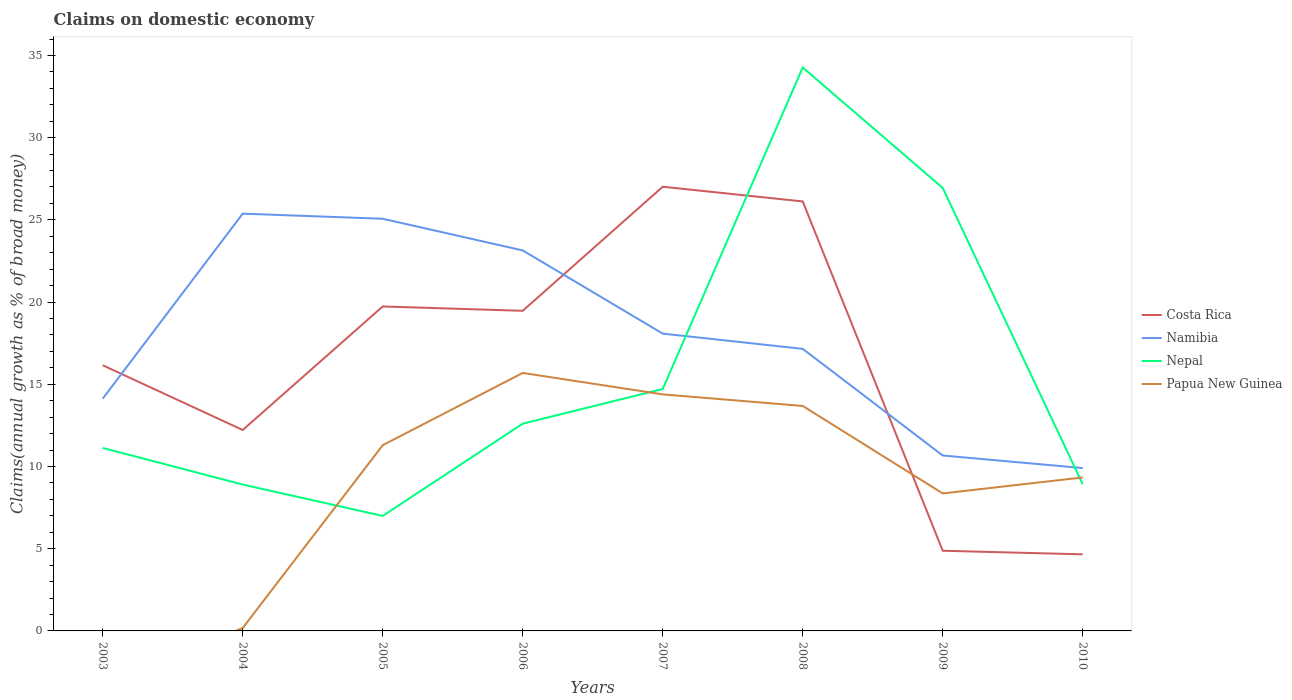How many different coloured lines are there?
Make the answer very short. 4. Does the line corresponding to Nepal intersect with the line corresponding to Papua New Guinea?
Make the answer very short. Yes. Is the number of lines equal to the number of legend labels?
Offer a terse response. No. Across all years, what is the maximum percentage of broad money claimed on domestic economy in Costa Rica?
Give a very brief answer. 4.66. What is the total percentage of broad money claimed on domestic economy in Namibia in the graph?
Your response must be concise. 8.22. What is the difference between the highest and the second highest percentage of broad money claimed on domestic economy in Papua New Guinea?
Your response must be concise. 15.69. What is the difference between the highest and the lowest percentage of broad money claimed on domestic economy in Nepal?
Offer a terse response. 2. Does the graph contain grids?
Provide a short and direct response. No. How are the legend labels stacked?
Provide a succinct answer. Vertical. What is the title of the graph?
Your answer should be very brief. Claims on domestic economy. Does "Czech Republic" appear as one of the legend labels in the graph?
Your answer should be very brief. No. What is the label or title of the X-axis?
Provide a short and direct response. Years. What is the label or title of the Y-axis?
Your answer should be very brief. Claims(annual growth as % of broad money). What is the Claims(annual growth as % of broad money) in Costa Rica in 2003?
Provide a succinct answer. 16.16. What is the Claims(annual growth as % of broad money) in Namibia in 2003?
Keep it short and to the point. 14.13. What is the Claims(annual growth as % of broad money) of Nepal in 2003?
Give a very brief answer. 11.13. What is the Claims(annual growth as % of broad money) of Papua New Guinea in 2003?
Offer a terse response. 0. What is the Claims(annual growth as % of broad money) in Costa Rica in 2004?
Keep it short and to the point. 12.22. What is the Claims(annual growth as % of broad money) in Namibia in 2004?
Provide a short and direct response. 25.38. What is the Claims(annual growth as % of broad money) of Nepal in 2004?
Keep it short and to the point. 8.9. What is the Claims(annual growth as % of broad money) in Papua New Guinea in 2004?
Offer a terse response. 0.18. What is the Claims(annual growth as % of broad money) of Costa Rica in 2005?
Provide a succinct answer. 19.73. What is the Claims(annual growth as % of broad money) of Namibia in 2005?
Keep it short and to the point. 25.07. What is the Claims(annual growth as % of broad money) of Nepal in 2005?
Your answer should be very brief. 6.99. What is the Claims(annual growth as % of broad money) of Papua New Guinea in 2005?
Your answer should be compact. 11.3. What is the Claims(annual growth as % of broad money) in Costa Rica in 2006?
Your answer should be compact. 19.47. What is the Claims(annual growth as % of broad money) of Namibia in 2006?
Offer a terse response. 23.14. What is the Claims(annual growth as % of broad money) of Nepal in 2006?
Give a very brief answer. 12.61. What is the Claims(annual growth as % of broad money) in Papua New Guinea in 2006?
Your answer should be compact. 15.69. What is the Claims(annual growth as % of broad money) of Costa Rica in 2007?
Make the answer very short. 27.02. What is the Claims(annual growth as % of broad money) in Namibia in 2007?
Offer a terse response. 18.08. What is the Claims(annual growth as % of broad money) of Nepal in 2007?
Provide a short and direct response. 14.71. What is the Claims(annual growth as % of broad money) of Papua New Guinea in 2007?
Your answer should be very brief. 14.39. What is the Claims(annual growth as % of broad money) of Costa Rica in 2008?
Your answer should be very brief. 26.12. What is the Claims(annual growth as % of broad money) of Namibia in 2008?
Give a very brief answer. 17.15. What is the Claims(annual growth as % of broad money) of Nepal in 2008?
Your answer should be compact. 34.27. What is the Claims(annual growth as % of broad money) in Papua New Guinea in 2008?
Ensure brevity in your answer.  13.68. What is the Claims(annual growth as % of broad money) in Costa Rica in 2009?
Give a very brief answer. 4.88. What is the Claims(annual growth as % of broad money) in Namibia in 2009?
Make the answer very short. 10.67. What is the Claims(annual growth as % of broad money) of Nepal in 2009?
Ensure brevity in your answer.  26.94. What is the Claims(annual growth as % of broad money) of Papua New Guinea in 2009?
Your response must be concise. 8.36. What is the Claims(annual growth as % of broad money) in Costa Rica in 2010?
Make the answer very short. 4.66. What is the Claims(annual growth as % of broad money) in Namibia in 2010?
Your answer should be compact. 9.9. What is the Claims(annual growth as % of broad money) of Nepal in 2010?
Your response must be concise. 8.92. What is the Claims(annual growth as % of broad money) in Papua New Guinea in 2010?
Give a very brief answer. 9.33. Across all years, what is the maximum Claims(annual growth as % of broad money) of Costa Rica?
Your answer should be very brief. 27.02. Across all years, what is the maximum Claims(annual growth as % of broad money) in Namibia?
Your answer should be compact. 25.38. Across all years, what is the maximum Claims(annual growth as % of broad money) in Nepal?
Give a very brief answer. 34.27. Across all years, what is the maximum Claims(annual growth as % of broad money) in Papua New Guinea?
Provide a succinct answer. 15.69. Across all years, what is the minimum Claims(annual growth as % of broad money) of Costa Rica?
Your response must be concise. 4.66. Across all years, what is the minimum Claims(annual growth as % of broad money) in Namibia?
Your response must be concise. 9.9. Across all years, what is the minimum Claims(annual growth as % of broad money) in Nepal?
Offer a very short reply. 6.99. What is the total Claims(annual growth as % of broad money) in Costa Rica in the graph?
Provide a short and direct response. 130.25. What is the total Claims(annual growth as % of broad money) of Namibia in the graph?
Provide a short and direct response. 143.52. What is the total Claims(annual growth as % of broad money) in Nepal in the graph?
Keep it short and to the point. 124.47. What is the total Claims(annual growth as % of broad money) in Papua New Guinea in the graph?
Provide a short and direct response. 72.93. What is the difference between the Claims(annual growth as % of broad money) in Costa Rica in 2003 and that in 2004?
Offer a very short reply. 3.94. What is the difference between the Claims(annual growth as % of broad money) of Namibia in 2003 and that in 2004?
Give a very brief answer. -11.25. What is the difference between the Claims(annual growth as % of broad money) of Nepal in 2003 and that in 2004?
Offer a very short reply. 2.23. What is the difference between the Claims(annual growth as % of broad money) of Costa Rica in 2003 and that in 2005?
Keep it short and to the point. -3.58. What is the difference between the Claims(annual growth as % of broad money) in Namibia in 2003 and that in 2005?
Ensure brevity in your answer.  -10.94. What is the difference between the Claims(annual growth as % of broad money) of Nepal in 2003 and that in 2005?
Provide a short and direct response. 4.14. What is the difference between the Claims(annual growth as % of broad money) of Costa Rica in 2003 and that in 2006?
Provide a succinct answer. -3.31. What is the difference between the Claims(annual growth as % of broad money) in Namibia in 2003 and that in 2006?
Provide a succinct answer. -9.02. What is the difference between the Claims(annual growth as % of broad money) in Nepal in 2003 and that in 2006?
Make the answer very short. -1.48. What is the difference between the Claims(annual growth as % of broad money) in Costa Rica in 2003 and that in 2007?
Offer a terse response. -10.86. What is the difference between the Claims(annual growth as % of broad money) in Namibia in 2003 and that in 2007?
Ensure brevity in your answer.  -3.96. What is the difference between the Claims(annual growth as % of broad money) in Nepal in 2003 and that in 2007?
Offer a very short reply. -3.58. What is the difference between the Claims(annual growth as % of broad money) of Costa Rica in 2003 and that in 2008?
Offer a terse response. -9.96. What is the difference between the Claims(annual growth as % of broad money) in Namibia in 2003 and that in 2008?
Keep it short and to the point. -3.03. What is the difference between the Claims(annual growth as % of broad money) in Nepal in 2003 and that in 2008?
Your response must be concise. -23.14. What is the difference between the Claims(annual growth as % of broad money) of Costa Rica in 2003 and that in 2009?
Your answer should be compact. 11.28. What is the difference between the Claims(annual growth as % of broad money) of Namibia in 2003 and that in 2009?
Give a very brief answer. 3.46. What is the difference between the Claims(annual growth as % of broad money) in Nepal in 2003 and that in 2009?
Your answer should be compact. -15.81. What is the difference between the Claims(annual growth as % of broad money) of Costa Rica in 2003 and that in 2010?
Your answer should be compact. 11.5. What is the difference between the Claims(annual growth as % of broad money) in Namibia in 2003 and that in 2010?
Your response must be concise. 4.22. What is the difference between the Claims(annual growth as % of broad money) in Nepal in 2003 and that in 2010?
Give a very brief answer. 2.21. What is the difference between the Claims(annual growth as % of broad money) of Costa Rica in 2004 and that in 2005?
Your response must be concise. -7.51. What is the difference between the Claims(annual growth as % of broad money) in Namibia in 2004 and that in 2005?
Keep it short and to the point. 0.31. What is the difference between the Claims(annual growth as % of broad money) of Nepal in 2004 and that in 2005?
Offer a terse response. 1.91. What is the difference between the Claims(annual growth as % of broad money) of Papua New Guinea in 2004 and that in 2005?
Make the answer very short. -11.12. What is the difference between the Claims(annual growth as % of broad money) of Costa Rica in 2004 and that in 2006?
Your answer should be very brief. -7.25. What is the difference between the Claims(annual growth as % of broad money) in Namibia in 2004 and that in 2006?
Your answer should be very brief. 2.24. What is the difference between the Claims(annual growth as % of broad money) in Nepal in 2004 and that in 2006?
Offer a very short reply. -3.7. What is the difference between the Claims(annual growth as % of broad money) in Papua New Guinea in 2004 and that in 2006?
Ensure brevity in your answer.  -15.51. What is the difference between the Claims(annual growth as % of broad money) in Costa Rica in 2004 and that in 2007?
Offer a very short reply. -14.8. What is the difference between the Claims(annual growth as % of broad money) of Namibia in 2004 and that in 2007?
Your answer should be very brief. 7.3. What is the difference between the Claims(annual growth as % of broad money) of Nepal in 2004 and that in 2007?
Offer a very short reply. -5.81. What is the difference between the Claims(annual growth as % of broad money) in Papua New Guinea in 2004 and that in 2007?
Keep it short and to the point. -14.21. What is the difference between the Claims(annual growth as % of broad money) of Costa Rica in 2004 and that in 2008?
Provide a short and direct response. -13.9. What is the difference between the Claims(annual growth as % of broad money) in Namibia in 2004 and that in 2008?
Your answer should be very brief. 8.22. What is the difference between the Claims(annual growth as % of broad money) of Nepal in 2004 and that in 2008?
Ensure brevity in your answer.  -25.37. What is the difference between the Claims(annual growth as % of broad money) of Papua New Guinea in 2004 and that in 2008?
Give a very brief answer. -13.5. What is the difference between the Claims(annual growth as % of broad money) in Costa Rica in 2004 and that in 2009?
Your answer should be very brief. 7.34. What is the difference between the Claims(annual growth as % of broad money) of Namibia in 2004 and that in 2009?
Keep it short and to the point. 14.71. What is the difference between the Claims(annual growth as % of broad money) in Nepal in 2004 and that in 2009?
Provide a short and direct response. -18.04. What is the difference between the Claims(annual growth as % of broad money) of Papua New Guinea in 2004 and that in 2009?
Provide a short and direct response. -8.18. What is the difference between the Claims(annual growth as % of broad money) in Costa Rica in 2004 and that in 2010?
Keep it short and to the point. 7.56. What is the difference between the Claims(annual growth as % of broad money) in Namibia in 2004 and that in 2010?
Your answer should be compact. 15.48. What is the difference between the Claims(annual growth as % of broad money) of Nepal in 2004 and that in 2010?
Provide a succinct answer. -0.02. What is the difference between the Claims(annual growth as % of broad money) of Papua New Guinea in 2004 and that in 2010?
Your answer should be compact. -9.15. What is the difference between the Claims(annual growth as % of broad money) in Costa Rica in 2005 and that in 2006?
Offer a terse response. 0.26. What is the difference between the Claims(annual growth as % of broad money) of Namibia in 2005 and that in 2006?
Your answer should be very brief. 1.93. What is the difference between the Claims(annual growth as % of broad money) of Nepal in 2005 and that in 2006?
Your answer should be very brief. -5.61. What is the difference between the Claims(annual growth as % of broad money) of Papua New Guinea in 2005 and that in 2006?
Your response must be concise. -4.4. What is the difference between the Claims(annual growth as % of broad money) of Costa Rica in 2005 and that in 2007?
Provide a short and direct response. -7.28. What is the difference between the Claims(annual growth as % of broad money) of Namibia in 2005 and that in 2007?
Ensure brevity in your answer.  6.99. What is the difference between the Claims(annual growth as % of broad money) in Nepal in 2005 and that in 2007?
Offer a terse response. -7.72. What is the difference between the Claims(annual growth as % of broad money) in Papua New Guinea in 2005 and that in 2007?
Offer a terse response. -3.09. What is the difference between the Claims(annual growth as % of broad money) in Costa Rica in 2005 and that in 2008?
Make the answer very short. -6.39. What is the difference between the Claims(annual growth as % of broad money) of Namibia in 2005 and that in 2008?
Keep it short and to the point. 7.91. What is the difference between the Claims(annual growth as % of broad money) of Nepal in 2005 and that in 2008?
Keep it short and to the point. -27.27. What is the difference between the Claims(annual growth as % of broad money) in Papua New Guinea in 2005 and that in 2008?
Provide a succinct answer. -2.39. What is the difference between the Claims(annual growth as % of broad money) in Costa Rica in 2005 and that in 2009?
Make the answer very short. 14.86. What is the difference between the Claims(annual growth as % of broad money) in Namibia in 2005 and that in 2009?
Your answer should be compact. 14.4. What is the difference between the Claims(annual growth as % of broad money) in Nepal in 2005 and that in 2009?
Keep it short and to the point. -19.95. What is the difference between the Claims(annual growth as % of broad money) of Papua New Guinea in 2005 and that in 2009?
Offer a very short reply. 2.93. What is the difference between the Claims(annual growth as % of broad money) in Costa Rica in 2005 and that in 2010?
Give a very brief answer. 15.08. What is the difference between the Claims(annual growth as % of broad money) of Namibia in 2005 and that in 2010?
Make the answer very short. 15.16. What is the difference between the Claims(annual growth as % of broad money) of Nepal in 2005 and that in 2010?
Your answer should be very brief. -1.93. What is the difference between the Claims(annual growth as % of broad money) of Papua New Guinea in 2005 and that in 2010?
Offer a terse response. 1.96. What is the difference between the Claims(annual growth as % of broad money) in Costa Rica in 2006 and that in 2007?
Ensure brevity in your answer.  -7.55. What is the difference between the Claims(annual growth as % of broad money) in Namibia in 2006 and that in 2007?
Offer a terse response. 5.06. What is the difference between the Claims(annual growth as % of broad money) in Nepal in 2006 and that in 2007?
Provide a short and direct response. -2.11. What is the difference between the Claims(annual growth as % of broad money) of Papua New Guinea in 2006 and that in 2007?
Provide a succinct answer. 1.3. What is the difference between the Claims(annual growth as % of broad money) in Costa Rica in 2006 and that in 2008?
Provide a succinct answer. -6.65. What is the difference between the Claims(annual growth as % of broad money) in Namibia in 2006 and that in 2008?
Your response must be concise. 5.99. What is the difference between the Claims(annual growth as % of broad money) of Nepal in 2006 and that in 2008?
Ensure brevity in your answer.  -21.66. What is the difference between the Claims(annual growth as % of broad money) in Papua New Guinea in 2006 and that in 2008?
Your answer should be compact. 2.01. What is the difference between the Claims(annual growth as % of broad money) of Costa Rica in 2006 and that in 2009?
Your response must be concise. 14.59. What is the difference between the Claims(annual growth as % of broad money) of Namibia in 2006 and that in 2009?
Give a very brief answer. 12.47. What is the difference between the Claims(annual growth as % of broad money) in Nepal in 2006 and that in 2009?
Your answer should be compact. -14.33. What is the difference between the Claims(annual growth as % of broad money) of Papua New Guinea in 2006 and that in 2009?
Your response must be concise. 7.33. What is the difference between the Claims(annual growth as % of broad money) in Costa Rica in 2006 and that in 2010?
Your answer should be very brief. 14.81. What is the difference between the Claims(annual growth as % of broad money) of Namibia in 2006 and that in 2010?
Keep it short and to the point. 13.24. What is the difference between the Claims(annual growth as % of broad money) in Nepal in 2006 and that in 2010?
Make the answer very short. 3.69. What is the difference between the Claims(annual growth as % of broad money) in Papua New Guinea in 2006 and that in 2010?
Ensure brevity in your answer.  6.36. What is the difference between the Claims(annual growth as % of broad money) in Costa Rica in 2007 and that in 2008?
Make the answer very short. 0.89. What is the difference between the Claims(annual growth as % of broad money) of Namibia in 2007 and that in 2008?
Make the answer very short. 0.93. What is the difference between the Claims(annual growth as % of broad money) of Nepal in 2007 and that in 2008?
Your answer should be compact. -19.55. What is the difference between the Claims(annual growth as % of broad money) of Papua New Guinea in 2007 and that in 2008?
Give a very brief answer. 0.7. What is the difference between the Claims(annual growth as % of broad money) in Costa Rica in 2007 and that in 2009?
Provide a succinct answer. 22.14. What is the difference between the Claims(annual growth as % of broad money) of Namibia in 2007 and that in 2009?
Your response must be concise. 7.41. What is the difference between the Claims(annual growth as % of broad money) in Nepal in 2007 and that in 2009?
Offer a very short reply. -12.23. What is the difference between the Claims(annual growth as % of broad money) in Papua New Guinea in 2007 and that in 2009?
Provide a short and direct response. 6.02. What is the difference between the Claims(annual growth as % of broad money) of Costa Rica in 2007 and that in 2010?
Your answer should be very brief. 22.36. What is the difference between the Claims(annual growth as % of broad money) in Namibia in 2007 and that in 2010?
Offer a terse response. 8.18. What is the difference between the Claims(annual growth as % of broad money) in Nepal in 2007 and that in 2010?
Provide a short and direct response. 5.79. What is the difference between the Claims(annual growth as % of broad money) of Papua New Guinea in 2007 and that in 2010?
Give a very brief answer. 5.05. What is the difference between the Claims(annual growth as % of broad money) in Costa Rica in 2008 and that in 2009?
Your response must be concise. 21.25. What is the difference between the Claims(annual growth as % of broad money) in Namibia in 2008 and that in 2009?
Keep it short and to the point. 6.49. What is the difference between the Claims(annual growth as % of broad money) in Nepal in 2008 and that in 2009?
Give a very brief answer. 7.33. What is the difference between the Claims(annual growth as % of broad money) in Papua New Guinea in 2008 and that in 2009?
Provide a succinct answer. 5.32. What is the difference between the Claims(annual growth as % of broad money) in Costa Rica in 2008 and that in 2010?
Provide a succinct answer. 21.46. What is the difference between the Claims(annual growth as % of broad money) of Namibia in 2008 and that in 2010?
Ensure brevity in your answer.  7.25. What is the difference between the Claims(annual growth as % of broad money) in Nepal in 2008 and that in 2010?
Offer a very short reply. 25.35. What is the difference between the Claims(annual growth as % of broad money) of Papua New Guinea in 2008 and that in 2010?
Give a very brief answer. 4.35. What is the difference between the Claims(annual growth as % of broad money) of Costa Rica in 2009 and that in 2010?
Ensure brevity in your answer.  0.22. What is the difference between the Claims(annual growth as % of broad money) in Namibia in 2009 and that in 2010?
Keep it short and to the point. 0.77. What is the difference between the Claims(annual growth as % of broad money) of Nepal in 2009 and that in 2010?
Ensure brevity in your answer.  18.02. What is the difference between the Claims(annual growth as % of broad money) in Papua New Guinea in 2009 and that in 2010?
Offer a terse response. -0.97. What is the difference between the Claims(annual growth as % of broad money) of Costa Rica in 2003 and the Claims(annual growth as % of broad money) of Namibia in 2004?
Keep it short and to the point. -9.22. What is the difference between the Claims(annual growth as % of broad money) in Costa Rica in 2003 and the Claims(annual growth as % of broad money) in Nepal in 2004?
Provide a succinct answer. 7.26. What is the difference between the Claims(annual growth as % of broad money) in Costa Rica in 2003 and the Claims(annual growth as % of broad money) in Papua New Guinea in 2004?
Your response must be concise. 15.98. What is the difference between the Claims(annual growth as % of broad money) of Namibia in 2003 and the Claims(annual growth as % of broad money) of Nepal in 2004?
Keep it short and to the point. 5.22. What is the difference between the Claims(annual growth as % of broad money) of Namibia in 2003 and the Claims(annual growth as % of broad money) of Papua New Guinea in 2004?
Ensure brevity in your answer.  13.95. What is the difference between the Claims(annual growth as % of broad money) of Nepal in 2003 and the Claims(annual growth as % of broad money) of Papua New Guinea in 2004?
Your answer should be very brief. 10.95. What is the difference between the Claims(annual growth as % of broad money) in Costa Rica in 2003 and the Claims(annual growth as % of broad money) in Namibia in 2005?
Your answer should be compact. -8.91. What is the difference between the Claims(annual growth as % of broad money) of Costa Rica in 2003 and the Claims(annual growth as % of broad money) of Nepal in 2005?
Ensure brevity in your answer.  9.16. What is the difference between the Claims(annual growth as % of broad money) in Costa Rica in 2003 and the Claims(annual growth as % of broad money) in Papua New Guinea in 2005?
Offer a very short reply. 4.86. What is the difference between the Claims(annual growth as % of broad money) in Namibia in 2003 and the Claims(annual growth as % of broad money) in Nepal in 2005?
Your answer should be compact. 7.13. What is the difference between the Claims(annual growth as % of broad money) of Namibia in 2003 and the Claims(annual growth as % of broad money) of Papua New Guinea in 2005?
Offer a very short reply. 2.83. What is the difference between the Claims(annual growth as % of broad money) in Nepal in 2003 and the Claims(annual growth as % of broad money) in Papua New Guinea in 2005?
Offer a very short reply. -0.17. What is the difference between the Claims(annual growth as % of broad money) of Costa Rica in 2003 and the Claims(annual growth as % of broad money) of Namibia in 2006?
Make the answer very short. -6.98. What is the difference between the Claims(annual growth as % of broad money) of Costa Rica in 2003 and the Claims(annual growth as % of broad money) of Nepal in 2006?
Your answer should be very brief. 3.55. What is the difference between the Claims(annual growth as % of broad money) of Costa Rica in 2003 and the Claims(annual growth as % of broad money) of Papua New Guinea in 2006?
Offer a very short reply. 0.47. What is the difference between the Claims(annual growth as % of broad money) of Namibia in 2003 and the Claims(annual growth as % of broad money) of Nepal in 2006?
Your response must be concise. 1.52. What is the difference between the Claims(annual growth as % of broad money) of Namibia in 2003 and the Claims(annual growth as % of broad money) of Papua New Guinea in 2006?
Provide a short and direct response. -1.57. What is the difference between the Claims(annual growth as % of broad money) of Nepal in 2003 and the Claims(annual growth as % of broad money) of Papua New Guinea in 2006?
Offer a very short reply. -4.56. What is the difference between the Claims(annual growth as % of broad money) of Costa Rica in 2003 and the Claims(annual growth as % of broad money) of Namibia in 2007?
Provide a short and direct response. -1.92. What is the difference between the Claims(annual growth as % of broad money) of Costa Rica in 2003 and the Claims(annual growth as % of broad money) of Nepal in 2007?
Offer a terse response. 1.44. What is the difference between the Claims(annual growth as % of broad money) in Costa Rica in 2003 and the Claims(annual growth as % of broad money) in Papua New Guinea in 2007?
Give a very brief answer. 1.77. What is the difference between the Claims(annual growth as % of broad money) of Namibia in 2003 and the Claims(annual growth as % of broad money) of Nepal in 2007?
Keep it short and to the point. -0.59. What is the difference between the Claims(annual growth as % of broad money) in Namibia in 2003 and the Claims(annual growth as % of broad money) in Papua New Guinea in 2007?
Make the answer very short. -0.26. What is the difference between the Claims(annual growth as % of broad money) of Nepal in 2003 and the Claims(annual growth as % of broad money) of Papua New Guinea in 2007?
Ensure brevity in your answer.  -3.26. What is the difference between the Claims(annual growth as % of broad money) in Costa Rica in 2003 and the Claims(annual growth as % of broad money) in Namibia in 2008?
Your response must be concise. -1. What is the difference between the Claims(annual growth as % of broad money) in Costa Rica in 2003 and the Claims(annual growth as % of broad money) in Nepal in 2008?
Keep it short and to the point. -18.11. What is the difference between the Claims(annual growth as % of broad money) of Costa Rica in 2003 and the Claims(annual growth as % of broad money) of Papua New Guinea in 2008?
Offer a terse response. 2.48. What is the difference between the Claims(annual growth as % of broad money) of Namibia in 2003 and the Claims(annual growth as % of broad money) of Nepal in 2008?
Your answer should be compact. -20.14. What is the difference between the Claims(annual growth as % of broad money) in Namibia in 2003 and the Claims(annual growth as % of broad money) in Papua New Guinea in 2008?
Your answer should be very brief. 0.44. What is the difference between the Claims(annual growth as % of broad money) in Nepal in 2003 and the Claims(annual growth as % of broad money) in Papua New Guinea in 2008?
Provide a succinct answer. -2.55. What is the difference between the Claims(annual growth as % of broad money) of Costa Rica in 2003 and the Claims(annual growth as % of broad money) of Namibia in 2009?
Make the answer very short. 5.49. What is the difference between the Claims(annual growth as % of broad money) in Costa Rica in 2003 and the Claims(annual growth as % of broad money) in Nepal in 2009?
Make the answer very short. -10.78. What is the difference between the Claims(annual growth as % of broad money) of Costa Rica in 2003 and the Claims(annual growth as % of broad money) of Papua New Guinea in 2009?
Provide a succinct answer. 7.8. What is the difference between the Claims(annual growth as % of broad money) of Namibia in 2003 and the Claims(annual growth as % of broad money) of Nepal in 2009?
Give a very brief answer. -12.82. What is the difference between the Claims(annual growth as % of broad money) of Namibia in 2003 and the Claims(annual growth as % of broad money) of Papua New Guinea in 2009?
Keep it short and to the point. 5.76. What is the difference between the Claims(annual growth as % of broad money) in Nepal in 2003 and the Claims(annual growth as % of broad money) in Papua New Guinea in 2009?
Keep it short and to the point. 2.77. What is the difference between the Claims(annual growth as % of broad money) in Costa Rica in 2003 and the Claims(annual growth as % of broad money) in Namibia in 2010?
Your response must be concise. 6.25. What is the difference between the Claims(annual growth as % of broad money) of Costa Rica in 2003 and the Claims(annual growth as % of broad money) of Nepal in 2010?
Make the answer very short. 7.24. What is the difference between the Claims(annual growth as % of broad money) of Costa Rica in 2003 and the Claims(annual growth as % of broad money) of Papua New Guinea in 2010?
Offer a very short reply. 6.82. What is the difference between the Claims(annual growth as % of broad money) in Namibia in 2003 and the Claims(annual growth as % of broad money) in Nepal in 2010?
Offer a terse response. 5.2. What is the difference between the Claims(annual growth as % of broad money) of Namibia in 2003 and the Claims(annual growth as % of broad money) of Papua New Guinea in 2010?
Ensure brevity in your answer.  4.79. What is the difference between the Claims(annual growth as % of broad money) in Nepal in 2003 and the Claims(annual growth as % of broad money) in Papua New Guinea in 2010?
Ensure brevity in your answer.  1.79. What is the difference between the Claims(annual growth as % of broad money) in Costa Rica in 2004 and the Claims(annual growth as % of broad money) in Namibia in 2005?
Provide a short and direct response. -12.85. What is the difference between the Claims(annual growth as % of broad money) in Costa Rica in 2004 and the Claims(annual growth as % of broad money) in Nepal in 2005?
Your answer should be very brief. 5.23. What is the difference between the Claims(annual growth as % of broad money) of Costa Rica in 2004 and the Claims(annual growth as % of broad money) of Papua New Guinea in 2005?
Provide a succinct answer. 0.93. What is the difference between the Claims(annual growth as % of broad money) of Namibia in 2004 and the Claims(annual growth as % of broad money) of Nepal in 2005?
Your answer should be very brief. 18.39. What is the difference between the Claims(annual growth as % of broad money) in Namibia in 2004 and the Claims(annual growth as % of broad money) in Papua New Guinea in 2005?
Provide a succinct answer. 14.08. What is the difference between the Claims(annual growth as % of broad money) in Nepal in 2004 and the Claims(annual growth as % of broad money) in Papua New Guinea in 2005?
Offer a very short reply. -2.39. What is the difference between the Claims(annual growth as % of broad money) in Costa Rica in 2004 and the Claims(annual growth as % of broad money) in Namibia in 2006?
Make the answer very short. -10.92. What is the difference between the Claims(annual growth as % of broad money) of Costa Rica in 2004 and the Claims(annual growth as % of broad money) of Nepal in 2006?
Your answer should be very brief. -0.39. What is the difference between the Claims(annual growth as % of broad money) in Costa Rica in 2004 and the Claims(annual growth as % of broad money) in Papua New Guinea in 2006?
Make the answer very short. -3.47. What is the difference between the Claims(annual growth as % of broad money) of Namibia in 2004 and the Claims(annual growth as % of broad money) of Nepal in 2006?
Make the answer very short. 12.77. What is the difference between the Claims(annual growth as % of broad money) in Namibia in 2004 and the Claims(annual growth as % of broad money) in Papua New Guinea in 2006?
Provide a short and direct response. 9.69. What is the difference between the Claims(annual growth as % of broad money) in Nepal in 2004 and the Claims(annual growth as % of broad money) in Papua New Guinea in 2006?
Provide a succinct answer. -6.79. What is the difference between the Claims(annual growth as % of broad money) of Costa Rica in 2004 and the Claims(annual growth as % of broad money) of Namibia in 2007?
Offer a very short reply. -5.86. What is the difference between the Claims(annual growth as % of broad money) in Costa Rica in 2004 and the Claims(annual growth as % of broad money) in Nepal in 2007?
Give a very brief answer. -2.49. What is the difference between the Claims(annual growth as % of broad money) of Costa Rica in 2004 and the Claims(annual growth as % of broad money) of Papua New Guinea in 2007?
Give a very brief answer. -2.17. What is the difference between the Claims(annual growth as % of broad money) of Namibia in 2004 and the Claims(annual growth as % of broad money) of Nepal in 2007?
Your answer should be compact. 10.67. What is the difference between the Claims(annual growth as % of broad money) of Namibia in 2004 and the Claims(annual growth as % of broad money) of Papua New Guinea in 2007?
Your answer should be compact. 10.99. What is the difference between the Claims(annual growth as % of broad money) in Nepal in 2004 and the Claims(annual growth as % of broad money) in Papua New Guinea in 2007?
Provide a succinct answer. -5.48. What is the difference between the Claims(annual growth as % of broad money) in Costa Rica in 2004 and the Claims(annual growth as % of broad money) in Namibia in 2008?
Your response must be concise. -4.93. What is the difference between the Claims(annual growth as % of broad money) of Costa Rica in 2004 and the Claims(annual growth as % of broad money) of Nepal in 2008?
Offer a terse response. -22.05. What is the difference between the Claims(annual growth as % of broad money) in Costa Rica in 2004 and the Claims(annual growth as % of broad money) in Papua New Guinea in 2008?
Provide a succinct answer. -1.46. What is the difference between the Claims(annual growth as % of broad money) in Namibia in 2004 and the Claims(annual growth as % of broad money) in Nepal in 2008?
Make the answer very short. -8.89. What is the difference between the Claims(annual growth as % of broad money) in Namibia in 2004 and the Claims(annual growth as % of broad money) in Papua New Guinea in 2008?
Ensure brevity in your answer.  11.7. What is the difference between the Claims(annual growth as % of broad money) in Nepal in 2004 and the Claims(annual growth as % of broad money) in Papua New Guinea in 2008?
Ensure brevity in your answer.  -4.78. What is the difference between the Claims(annual growth as % of broad money) of Costa Rica in 2004 and the Claims(annual growth as % of broad money) of Namibia in 2009?
Provide a short and direct response. 1.55. What is the difference between the Claims(annual growth as % of broad money) of Costa Rica in 2004 and the Claims(annual growth as % of broad money) of Nepal in 2009?
Provide a short and direct response. -14.72. What is the difference between the Claims(annual growth as % of broad money) of Costa Rica in 2004 and the Claims(annual growth as % of broad money) of Papua New Guinea in 2009?
Provide a succinct answer. 3.86. What is the difference between the Claims(annual growth as % of broad money) of Namibia in 2004 and the Claims(annual growth as % of broad money) of Nepal in 2009?
Give a very brief answer. -1.56. What is the difference between the Claims(annual growth as % of broad money) of Namibia in 2004 and the Claims(annual growth as % of broad money) of Papua New Guinea in 2009?
Keep it short and to the point. 17.02. What is the difference between the Claims(annual growth as % of broad money) in Nepal in 2004 and the Claims(annual growth as % of broad money) in Papua New Guinea in 2009?
Keep it short and to the point. 0.54. What is the difference between the Claims(annual growth as % of broad money) in Costa Rica in 2004 and the Claims(annual growth as % of broad money) in Namibia in 2010?
Provide a short and direct response. 2.32. What is the difference between the Claims(annual growth as % of broad money) of Costa Rica in 2004 and the Claims(annual growth as % of broad money) of Nepal in 2010?
Your response must be concise. 3.3. What is the difference between the Claims(annual growth as % of broad money) of Costa Rica in 2004 and the Claims(annual growth as % of broad money) of Papua New Guinea in 2010?
Offer a very short reply. 2.89. What is the difference between the Claims(annual growth as % of broad money) of Namibia in 2004 and the Claims(annual growth as % of broad money) of Nepal in 2010?
Your answer should be compact. 16.46. What is the difference between the Claims(annual growth as % of broad money) of Namibia in 2004 and the Claims(annual growth as % of broad money) of Papua New Guinea in 2010?
Ensure brevity in your answer.  16.04. What is the difference between the Claims(annual growth as % of broad money) of Nepal in 2004 and the Claims(annual growth as % of broad money) of Papua New Guinea in 2010?
Give a very brief answer. -0.43. What is the difference between the Claims(annual growth as % of broad money) in Costa Rica in 2005 and the Claims(annual growth as % of broad money) in Namibia in 2006?
Your answer should be compact. -3.41. What is the difference between the Claims(annual growth as % of broad money) of Costa Rica in 2005 and the Claims(annual growth as % of broad money) of Nepal in 2006?
Your response must be concise. 7.13. What is the difference between the Claims(annual growth as % of broad money) of Costa Rica in 2005 and the Claims(annual growth as % of broad money) of Papua New Guinea in 2006?
Give a very brief answer. 4.04. What is the difference between the Claims(annual growth as % of broad money) in Namibia in 2005 and the Claims(annual growth as % of broad money) in Nepal in 2006?
Provide a succinct answer. 12.46. What is the difference between the Claims(annual growth as % of broad money) in Namibia in 2005 and the Claims(annual growth as % of broad money) in Papua New Guinea in 2006?
Provide a succinct answer. 9.38. What is the difference between the Claims(annual growth as % of broad money) in Nepal in 2005 and the Claims(annual growth as % of broad money) in Papua New Guinea in 2006?
Ensure brevity in your answer.  -8.7. What is the difference between the Claims(annual growth as % of broad money) of Costa Rica in 2005 and the Claims(annual growth as % of broad money) of Namibia in 2007?
Ensure brevity in your answer.  1.65. What is the difference between the Claims(annual growth as % of broad money) in Costa Rica in 2005 and the Claims(annual growth as % of broad money) in Nepal in 2007?
Offer a very short reply. 5.02. What is the difference between the Claims(annual growth as % of broad money) in Costa Rica in 2005 and the Claims(annual growth as % of broad money) in Papua New Guinea in 2007?
Your response must be concise. 5.35. What is the difference between the Claims(annual growth as % of broad money) in Namibia in 2005 and the Claims(annual growth as % of broad money) in Nepal in 2007?
Make the answer very short. 10.35. What is the difference between the Claims(annual growth as % of broad money) in Namibia in 2005 and the Claims(annual growth as % of broad money) in Papua New Guinea in 2007?
Offer a terse response. 10.68. What is the difference between the Claims(annual growth as % of broad money) in Nepal in 2005 and the Claims(annual growth as % of broad money) in Papua New Guinea in 2007?
Your answer should be compact. -7.39. What is the difference between the Claims(annual growth as % of broad money) of Costa Rica in 2005 and the Claims(annual growth as % of broad money) of Namibia in 2008?
Ensure brevity in your answer.  2.58. What is the difference between the Claims(annual growth as % of broad money) of Costa Rica in 2005 and the Claims(annual growth as % of broad money) of Nepal in 2008?
Ensure brevity in your answer.  -14.53. What is the difference between the Claims(annual growth as % of broad money) in Costa Rica in 2005 and the Claims(annual growth as % of broad money) in Papua New Guinea in 2008?
Your answer should be compact. 6.05. What is the difference between the Claims(annual growth as % of broad money) of Namibia in 2005 and the Claims(annual growth as % of broad money) of Nepal in 2008?
Your answer should be compact. -9.2. What is the difference between the Claims(annual growth as % of broad money) of Namibia in 2005 and the Claims(annual growth as % of broad money) of Papua New Guinea in 2008?
Your answer should be compact. 11.38. What is the difference between the Claims(annual growth as % of broad money) in Nepal in 2005 and the Claims(annual growth as % of broad money) in Papua New Guinea in 2008?
Your answer should be very brief. -6.69. What is the difference between the Claims(annual growth as % of broad money) of Costa Rica in 2005 and the Claims(annual growth as % of broad money) of Namibia in 2009?
Your answer should be very brief. 9.06. What is the difference between the Claims(annual growth as % of broad money) in Costa Rica in 2005 and the Claims(annual growth as % of broad money) in Nepal in 2009?
Your answer should be compact. -7.21. What is the difference between the Claims(annual growth as % of broad money) of Costa Rica in 2005 and the Claims(annual growth as % of broad money) of Papua New Guinea in 2009?
Make the answer very short. 11.37. What is the difference between the Claims(annual growth as % of broad money) of Namibia in 2005 and the Claims(annual growth as % of broad money) of Nepal in 2009?
Your answer should be very brief. -1.87. What is the difference between the Claims(annual growth as % of broad money) of Namibia in 2005 and the Claims(annual growth as % of broad money) of Papua New Guinea in 2009?
Ensure brevity in your answer.  16.71. What is the difference between the Claims(annual growth as % of broad money) of Nepal in 2005 and the Claims(annual growth as % of broad money) of Papua New Guinea in 2009?
Your answer should be compact. -1.37. What is the difference between the Claims(annual growth as % of broad money) of Costa Rica in 2005 and the Claims(annual growth as % of broad money) of Namibia in 2010?
Ensure brevity in your answer.  9.83. What is the difference between the Claims(annual growth as % of broad money) in Costa Rica in 2005 and the Claims(annual growth as % of broad money) in Nepal in 2010?
Give a very brief answer. 10.81. What is the difference between the Claims(annual growth as % of broad money) of Costa Rica in 2005 and the Claims(annual growth as % of broad money) of Papua New Guinea in 2010?
Provide a succinct answer. 10.4. What is the difference between the Claims(annual growth as % of broad money) of Namibia in 2005 and the Claims(annual growth as % of broad money) of Nepal in 2010?
Make the answer very short. 16.15. What is the difference between the Claims(annual growth as % of broad money) in Namibia in 2005 and the Claims(annual growth as % of broad money) in Papua New Guinea in 2010?
Make the answer very short. 15.73. What is the difference between the Claims(annual growth as % of broad money) of Nepal in 2005 and the Claims(annual growth as % of broad money) of Papua New Guinea in 2010?
Provide a short and direct response. -2.34. What is the difference between the Claims(annual growth as % of broad money) in Costa Rica in 2006 and the Claims(annual growth as % of broad money) in Namibia in 2007?
Your answer should be very brief. 1.39. What is the difference between the Claims(annual growth as % of broad money) of Costa Rica in 2006 and the Claims(annual growth as % of broad money) of Nepal in 2007?
Offer a very short reply. 4.76. What is the difference between the Claims(annual growth as % of broad money) in Costa Rica in 2006 and the Claims(annual growth as % of broad money) in Papua New Guinea in 2007?
Provide a short and direct response. 5.08. What is the difference between the Claims(annual growth as % of broad money) of Namibia in 2006 and the Claims(annual growth as % of broad money) of Nepal in 2007?
Give a very brief answer. 8.43. What is the difference between the Claims(annual growth as % of broad money) in Namibia in 2006 and the Claims(annual growth as % of broad money) in Papua New Guinea in 2007?
Provide a succinct answer. 8.76. What is the difference between the Claims(annual growth as % of broad money) in Nepal in 2006 and the Claims(annual growth as % of broad money) in Papua New Guinea in 2007?
Your answer should be very brief. -1.78. What is the difference between the Claims(annual growth as % of broad money) of Costa Rica in 2006 and the Claims(annual growth as % of broad money) of Namibia in 2008?
Your answer should be compact. 2.32. What is the difference between the Claims(annual growth as % of broad money) in Costa Rica in 2006 and the Claims(annual growth as % of broad money) in Nepal in 2008?
Make the answer very short. -14.8. What is the difference between the Claims(annual growth as % of broad money) in Costa Rica in 2006 and the Claims(annual growth as % of broad money) in Papua New Guinea in 2008?
Your response must be concise. 5.79. What is the difference between the Claims(annual growth as % of broad money) of Namibia in 2006 and the Claims(annual growth as % of broad money) of Nepal in 2008?
Give a very brief answer. -11.13. What is the difference between the Claims(annual growth as % of broad money) of Namibia in 2006 and the Claims(annual growth as % of broad money) of Papua New Guinea in 2008?
Give a very brief answer. 9.46. What is the difference between the Claims(annual growth as % of broad money) of Nepal in 2006 and the Claims(annual growth as % of broad money) of Papua New Guinea in 2008?
Offer a very short reply. -1.08. What is the difference between the Claims(annual growth as % of broad money) in Costa Rica in 2006 and the Claims(annual growth as % of broad money) in Namibia in 2009?
Your answer should be compact. 8.8. What is the difference between the Claims(annual growth as % of broad money) of Costa Rica in 2006 and the Claims(annual growth as % of broad money) of Nepal in 2009?
Provide a succinct answer. -7.47. What is the difference between the Claims(annual growth as % of broad money) of Costa Rica in 2006 and the Claims(annual growth as % of broad money) of Papua New Guinea in 2009?
Ensure brevity in your answer.  11.11. What is the difference between the Claims(annual growth as % of broad money) in Namibia in 2006 and the Claims(annual growth as % of broad money) in Nepal in 2009?
Your response must be concise. -3.8. What is the difference between the Claims(annual growth as % of broad money) in Namibia in 2006 and the Claims(annual growth as % of broad money) in Papua New Guinea in 2009?
Your answer should be very brief. 14.78. What is the difference between the Claims(annual growth as % of broad money) of Nepal in 2006 and the Claims(annual growth as % of broad money) of Papua New Guinea in 2009?
Make the answer very short. 4.24. What is the difference between the Claims(annual growth as % of broad money) of Costa Rica in 2006 and the Claims(annual growth as % of broad money) of Namibia in 2010?
Provide a short and direct response. 9.57. What is the difference between the Claims(annual growth as % of broad money) in Costa Rica in 2006 and the Claims(annual growth as % of broad money) in Nepal in 2010?
Your answer should be compact. 10.55. What is the difference between the Claims(annual growth as % of broad money) in Costa Rica in 2006 and the Claims(annual growth as % of broad money) in Papua New Guinea in 2010?
Give a very brief answer. 10.14. What is the difference between the Claims(annual growth as % of broad money) in Namibia in 2006 and the Claims(annual growth as % of broad money) in Nepal in 2010?
Offer a very short reply. 14.22. What is the difference between the Claims(annual growth as % of broad money) of Namibia in 2006 and the Claims(annual growth as % of broad money) of Papua New Guinea in 2010?
Your answer should be compact. 13.81. What is the difference between the Claims(annual growth as % of broad money) in Nepal in 2006 and the Claims(annual growth as % of broad money) in Papua New Guinea in 2010?
Your response must be concise. 3.27. What is the difference between the Claims(annual growth as % of broad money) in Costa Rica in 2007 and the Claims(annual growth as % of broad money) in Namibia in 2008?
Your answer should be compact. 9.86. What is the difference between the Claims(annual growth as % of broad money) of Costa Rica in 2007 and the Claims(annual growth as % of broad money) of Nepal in 2008?
Ensure brevity in your answer.  -7.25. What is the difference between the Claims(annual growth as % of broad money) of Costa Rica in 2007 and the Claims(annual growth as % of broad money) of Papua New Guinea in 2008?
Provide a short and direct response. 13.33. What is the difference between the Claims(annual growth as % of broad money) in Namibia in 2007 and the Claims(annual growth as % of broad money) in Nepal in 2008?
Offer a very short reply. -16.19. What is the difference between the Claims(annual growth as % of broad money) of Namibia in 2007 and the Claims(annual growth as % of broad money) of Papua New Guinea in 2008?
Ensure brevity in your answer.  4.4. What is the difference between the Claims(annual growth as % of broad money) in Nepal in 2007 and the Claims(annual growth as % of broad money) in Papua New Guinea in 2008?
Your response must be concise. 1.03. What is the difference between the Claims(annual growth as % of broad money) of Costa Rica in 2007 and the Claims(annual growth as % of broad money) of Namibia in 2009?
Your answer should be very brief. 16.35. What is the difference between the Claims(annual growth as % of broad money) in Costa Rica in 2007 and the Claims(annual growth as % of broad money) in Nepal in 2009?
Your response must be concise. 0.08. What is the difference between the Claims(annual growth as % of broad money) of Costa Rica in 2007 and the Claims(annual growth as % of broad money) of Papua New Guinea in 2009?
Provide a short and direct response. 18.65. What is the difference between the Claims(annual growth as % of broad money) in Namibia in 2007 and the Claims(annual growth as % of broad money) in Nepal in 2009?
Provide a short and direct response. -8.86. What is the difference between the Claims(annual growth as % of broad money) in Namibia in 2007 and the Claims(annual growth as % of broad money) in Papua New Guinea in 2009?
Offer a very short reply. 9.72. What is the difference between the Claims(annual growth as % of broad money) of Nepal in 2007 and the Claims(annual growth as % of broad money) of Papua New Guinea in 2009?
Offer a terse response. 6.35. What is the difference between the Claims(annual growth as % of broad money) of Costa Rica in 2007 and the Claims(annual growth as % of broad money) of Namibia in 2010?
Provide a succinct answer. 17.11. What is the difference between the Claims(annual growth as % of broad money) in Costa Rica in 2007 and the Claims(annual growth as % of broad money) in Nepal in 2010?
Offer a very short reply. 18.09. What is the difference between the Claims(annual growth as % of broad money) in Costa Rica in 2007 and the Claims(annual growth as % of broad money) in Papua New Guinea in 2010?
Give a very brief answer. 17.68. What is the difference between the Claims(annual growth as % of broad money) of Namibia in 2007 and the Claims(annual growth as % of broad money) of Nepal in 2010?
Offer a terse response. 9.16. What is the difference between the Claims(annual growth as % of broad money) in Namibia in 2007 and the Claims(annual growth as % of broad money) in Papua New Guinea in 2010?
Your response must be concise. 8.75. What is the difference between the Claims(annual growth as % of broad money) of Nepal in 2007 and the Claims(annual growth as % of broad money) of Papua New Guinea in 2010?
Make the answer very short. 5.38. What is the difference between the Claims(annual growth as % of broad money) in Costa Rica in 2008 and the Claims(annual growth as % of broad money) in Namibia in 2009?
Provide a short and direct response. 15.45. What is the difference between the Claims(annual growth as % of broad money) of Costa Rica in 2008 and the Claims(annual growth as % of broad money) of Nepal in 2009?
Provide a short and direct response. -0.82. What is the difference between the Claims(annual growth as % of broad money) of Costa Rica in 2008 and the Claims(annual growth as % of broad money) of Papua New Guinea in 2009?
Give a very brief answer. 17.76. What is the difference between the Claims(annual growth as % of broad money) of Namibia in 2008 and the Claims(annual growth as % of broad money) of Nepal in 2009?
Offer a terse response. -9.79. What is the difference between the Claims(annual growth as % of broad money) in Namibia in 2008 and the Claims(annual growth as % of broad money) in Papua New Guinea in 2009?
Your answer should be very brief. 8.79. What is the difference between the Claims(annual growth as % of broad money) in Nepal in 2008 and the Claims(annual growth as % of broad money) in Papua New Guinea in 2009?
Offer a terse response. 25.91. What is the difference between the Claims(annual growth as % of broad money) of Costa Rica in 2008 and the Claims(annual growth as % of broad money) of Namibia in 2010?
Your answer should be compact. 16.22. What is the difference between the Claims(annual growth as % of broad money) in Costa Rica in 2008 and the Claims(annual growth as % of broad money) in Nepal in 2010?
Offer a terse response. 17.2. What is the difference between the Claims(annual growth as % of broad money) in Costa Rica in 2008 and the Claims(annual growth as % of broad money) in Papua New Guinea in 2010?
Your answer should be compact. 16.79. What is the difference between the Claims(annual growth as % of broad money) in Namibia in 2008 and the Claims(annual growth as % of broad money) in Nepal in 2010?
Keep it short and to the point. 8.23. What is the difference between the Claims(annual growth as % of broad money) of Namibia in 2008 and the Claims(annual growth as % of broad money) of Papua New Guinea in 2010?
Offer a terse response. 7.82. What is the difference between the Claims(annual growth as % of broad money) of Nepal in 2008 and the Claims(annual growth as % of broad money) of Papua New Guinea in 2010?
Your answer should be very brief. 24.93. What is the difference between the Claims(annual growth as % of broad money) in Costa Rica in 2009 and the Claims(annual growth as % of broad money) in Namibia in 2010?
Give a very brief answer. -5.03. What is the difference between the Claims(annual growth as % of broad money) in Costa Rica in 2009 and the Claims(annual growth as % of broad money) in Nepal in 2010?
Provide a succinct answer. -4.04. What is the difference between the Claims(annual growth as % of broad money) in Costa Rica in 2009 and the Claims(annual growth as % of broad money) in Papua New Guinea in 2010?
Offer a terse response. -4.46. What is the difference between the Claims(annual growth as % of broad money) in Namibia in 2009 and the Claims(annual growth as % of broad money) in Nepal in 2010?
Provide a succinct answer. 1.75. What is the difference between the Claims(annual growth as % of broad money) of Namibia in 2009 and the Claims(annual growth as % of broad money) of Papua New Guinea in 2010?
Ensure brevity in your answer.  1.33. What is the difference between the Claims(annual growth as % of broad money) of Nepal in 2009 and the Claims(annual growth as % of broad money) of Papua New Guinea in 2010?
Provide a succinct answer. 17.61. What is the average Claims(annual growth as % of broad money) of Costa Rica per year?
Your response must be concise. 16.28. What is the average Claims(annual growth as % of broad money) of Namibia per year?
Your answer should be compact. 17.94. What is the average Claims(annual growth as % of broad money) of Nepal per year?
Offer a very short reply. 15.56. What is the average Claims(annual growth as % of broad money) of Papua New Guinea per year?
Provide a short and direct response. 9.12. In the year 2003, what is the difference between the Claims(annual growth as % of broad money) in Costa Rica and Claims(annual growth as % of broad money) in Namibia?
Keep it short and to the point. 2.03. In the year 2003, what is the difference between the Claims(annual growth as % of broad money) of Costa Rica and Claims(annual growth as % of broad money) of Nepal?
Keep it short and to the point. 5.03. In the year 2003, what is the difference between the Claims(annual growth as % of broad money) of Namibia and Claims(annual growth as % of broad money) of Nepal?
Your answer should be very brief. 3. In the year 2004, what is the difference between the Claims(annual growth as % of broad money) in Costa Rica and Claims(annual growth as % of broad money) in Namibia?
Keep it short and to the point. -13.16. In the year 2004, what is the difference between the Claims(annual growth as % of broad money) in Costa Rica and Claims(annual growth as % of broad money) in Nepal?
Keep it short and to the point. 3.32. In the year 2004, what is the difference between the Claims(annual growth as % of broad money) in Costa Rica and Claims(annual growth as % of broad money) in Papua New Guinea?
Provide a short and direct response. 12.04. In the year 2004, what is the difference between the Claims(annual growth as % of broad money) in Namibia and Claims(annual growth as % of broad money) in Nepal?
Give a very brief answer. 16.48. In the year 2004, what is the difference between the Claims(annual growth as % of broad money) of Namibia and Claims(annual growth as % of broad money) of Papua New Guinea?
Offer a terse response. 25.2. In the year 2004, what is the difference between the Claims(annual growth as % of broad money) of Nepal and Claims(annual growth as % of broad money) of Papua New Guinea?
Provide a succinct answer. 8.72. In the year 2005, what is the difference between the Claims(annual growth as % of broad money) in Costa Rica and Claims(annual growth as % of broad money) in Namibia?
Keep it short and to the point. -5.33. In the year 2005, what is the difference between the Claims(annual growth as % of broad money) of Costa Rica and Claims(annual growth as % of broad money) of Nepal?
Provide a short and direct response. 12.74. In the year 2005, what is the difference between the Claims(annual growth as % of broad money) in Costa Rica and Claims(annual growth as % of broad money) in Papua New Guinea?
Offer a very short reply. 8.44. In the year 2005, what is the difference between the Claims(annual growth as % of broad money) of Namibia and Claims(annual growth as % of broad money) of Nepal?
Provide a short and direct response. 18.07. In the year 2005, what is the difference between the Claims(annual growth as % of broad money) of Namibia and Claims(annual growth as % of broad money) of Papua New Guinea?
Your response must be concise. 13.77. In the year 2005, what is the difference between the Claims(annual growth as % of broad money) in Nepal and Claims(annual growth as % of broad money) in Papua New Guinea?
Offer a very short reply. -4.3. In the year 2006, what is the difference between the Claims(annual growth as % of broad money) of Costa Rica and Claims(annual growth as % of broad money) of Namibia?
Keep it short and to the point. -3.67. In the year 2006, what is the difference between the Claims(annual growth as % of broad money) of Costa Rica and Claims(annual growth as % of broad money) of Nepal?
Your response must be concise. 6.86. In the year 2006, what is the difference between the Claims(annual growth as % of broad money) in Costa Rica and Claims(annual growth as % of broad money) in Papua New Guinea?
Ensure brevity in your answer.  3.78. In the year 2006, what is the difference between the Claims(annual growth as % of broad money) in Namibia and Claims(annual growth as % of broad money) in Nepal?
Offer a terse response. 10.54. In the year 2006, what is the difference between the Claims(annual growth as % of broad money) of Namibia and Claims(annual growth as % of broad money) of Papua New Guinea?
Your answer should be compact. 7.45. In the year 2006, what is the difference between the Claims(annual growth as % of broad money) of Nepal and Claims(annual growth as % of broad money) of Papua New Guinea?
Your answer should be very brief. -3.09. In the year 2007, what is the difference between the Claims(annual growth as % of broad money) in Costa Rica and Claims(annual growth as % of broad money) in Namibia?
Offer a terse response. 8.93. In the year 2007, what is the difference between the Claims(annual growth as % of broad money) in Costa Rica and Claims(annual growth as % of broad money) in Nepal?
Your answer should be very brief. 12.3. In the year 2007, what is the difference between the Claims(annual growth as % of broad money) in Costa Rica and Claims(annual growth as % of broad money) in Papua New Guinea?
Offer a terse response. 12.63. In the year 2007, what is the difference between the Claims(annual growth as % of broad money) of Namibia and Claims(annual growth as % of broad money) of Nepal?
Offer a very short reply. 3.37. In the year 2007, what is the difference between the Claims(annual growth as % of broad money) of Namibia and Claims(annual growth as % of broad money) of Papua New Guinea?
Ensure brevity in your answer.  3.7. In the year 2007, what is the difference between the Claims(annual growth as % of broad money) in Nepal and Claims(annual growth as % of broad money) in Papua New Guinea?
Provide a short and direct response. 0.33. In the year 2008, what is the difference between the Claims(annual growth as % of broad money) of Costa Rica and Claims(annual growth as % of broad money) of Namibia?
Your answer should be very brief. 8.97. In the year 2008, what is the difference between the Claims(annual growth as % of broad money) in Costa Rica and Claims(annual growth as % of broad money) in Nepal?
Your answer should be very brief. -8.15. In the year 2008, what is the difference between the Claims(annual growth as % of broad money) in Costa Rica and Claims(annual growth as % of broad money) in Papua New Guinea?
Offer a very short reply. 12.44. In the year 2008, what is the difference between the Claims(annual growth as % of broad money) of Namibia and Claims(annual growth as % of broad money) of Nepal?
Your response must be concise. -17.11. In the year 2008, what is the difference between the Claims(annual growth as % of broad money) in Namibia and Claims(annual growth as % of broad money) in Papua New Guinea?
Your answer should be very brief. 3.47. In the year 2008, what is the difference between the Claims(annual growth as % of broad money) of Nepal and Claims(annual growth as % of broad money) of Papua New Guinea?
Give a very brief answer. 20.59. In the year 2009, what is the difference between the Claims(annual growth as % of broad money) in Costa Rica and Claims(annual growth as % of broad money) in Namibia?
Your answer should be very brief. -5.79. In the year 2009, what is the difference between the Claims(annual growth as % of broad money) in Costa Rica and Claims(annual growth as % of broad money) in Nepal?
Your answer should be very brief. -22.06. In the year 2009, what is the difference between the Claims(annual growth as % of broad money) in Costa Rica and Claims(annual growth as % of broad money) in Papua New Guinea?
Provide a short and direct response. -3.49. In the year 2009, what is the difference between the Claims(annual growth as % of broad money) of Namibia and Claims(annual growth as % of broad money) of Nepal?
Your answer should be compact. -16.27. In the year 2009, what is the difference between the Claims(annual growth as % of broad money) in Namibia and Claims(annual growth as % of broad money) in Papua New Guinea?
Provide a succinct answer. 2.31. In the year 2009, what is the difference between the Claims(annual growth as % of broad money) of Nepal and Claims(annual growth as % of broad money) of Papua New Guinea?
Offer a terse response. 18.58. In the year 2010, what is the difference between the Claims(annual growth as % of broad money) in Costa Rica and Claims(annual growth as % of broad money) in Namibia?
Offer a terse response. -5.25. In the year 2010, what is the difference between the Claims(annual growth as % of broad money) in Costa Rica and Claims(annual growth as % of broad money) in Nepal?
Your answer should be compact. -4.26. In the year 2010, what is the difference between the Claims(annual growth as % of broad money) in Costa Rica and Claims(annual growth as % of broad money) in Papua New Guinea?
Give a very brief answer. -4.68. In the year 2010, what is the difference between the Claims(annual growth as % of broad money) of Namibia and Claims(annual growth as % of broad money) of Nepal?
Provide a short and direct response. 0.98. In the year 2010, what is the difference between the Claims(annual growth as % of broad money) of Namibia and Claims(annual growth as % of broad money) of Papua New Guinea?
Offer a terse response. 0.57. In the year 2010, what is the difference between the Claims(annual growth as % of broad money) in Nepal and Claims(annual growth as % of broad money) in Papua New Guinea?
Provide a succinct answer. -0.41. What is the ratio of the Claims(annual growth as % of broad money) of Costa Rica in 2003 to that in 2004?
Keep it short and to the point. 1.32. What is the ratio of the Claims(annual growth as % of broad money) in Namibia in 2003 to that in 2004?
Your response must be concise. 0.56. What is the ratio of the Claims(annual growth as % of broad money) of Nepal in 2003 to that in 2004?
Your answer should be very brief. 1.25. What is the ratio of the Claims(annual growth as % of broad money) in Costa Rica in 2003 to that in 2005?
Give a very brief answer. 0.82. What is the ratio of the Claims(annual growth as % of broad money) of Namibia in 2003 to that in 2005?
Offer a very short reply. 0.56. What is the ratio of the Claims(annual growth as % of broad money) of Nepal in 2003 to that in 2005?
Your answer should be very brief. 1.59. What is the ratio of the Claims(annual growth as % of broad money) in Costa Rica in 2003 to that in 2006?
Your answer should be very brief. 0.83. What is the ratio of the Claims(annual growth as % of broad money) in Namibia in 2003 to that in 2006?
Keep it short and to the point. 0.61. What is the ratio of the Claims(annual growth as % of broad money) of Nepal in 2003 to that in 2006?
Make the answer very short. 0.88. What is the ratio of the Claims(annual growth as % of broad money) in Costa Rica in 2003 to that in 2007?
Make the answer very short. 0.6. What is the ratio of the Claims(annual growth as % of broad money) in Namibia in 2003 to that in 2007?
Your answer should be compact. 0.78. What is the ratio of the Claims(annual growth as % of broad money) of Nepal in 2003 to that in 2007?
Provide a short and direct response. 0.76. What is the ratio of the Claims(annual growth as % of broad money) in Costa Rica in 2003 to that in 2008?
Provide a short and direct response. 0.62. What is the ratio of the Claims(annual growth as % of broad money) of Namibia in 2003 to that in 2008?
Ensure brevity in your answer.  0.82. What is the ratio of the Claims(annual growth as % of broad money) in Nepal in 2003 to that in 2008?
Your answer should be very brief. 0.32. What is the ratio of the Claims(annual growth as % of broad money) in Costa Rica in 2003 to that in 2009?
Offer a terse response. 3.31. What is the ratio of the Claims(annual growth as % of broad money) in Namibia in 2003 to that in 2009?
Provide a succinct answer. 1.32. What is the ratio of the Claims(annual growth as % of broad money) in Nepal in 2003 to that in 2009?
Make the answer very short. 0.41. What is the ratio of the Claims(annual growth as % of broad money) of Costa Rica in 2003 to that in 2010?
Make the answer very short. 3.47. What is the ratio of the Claims(annual growth as % of broad money) in Namibia in 2003 to that in 2010?
Offer a very short reply. 1.43. What is the ratio of the Claims(annual growth as % of broad money) of Nepal in 2003 to that in 2010?
Make the answer very short. 1.25. What is the ratio of the Claims(annual growth as % of broad money) in Costa Rica in 2004 to that in 2005?
Provide a succinct answer. 0.62. What is the ratio of the Claims(annual growth as % of broad money) of Namibia in 2004 to that in 2005?
Offer a very short reply. 1.01. What is the ratio of the Claims(annual growth as % of broad money) in Nepal in 2004 to that in 2005?
Offer a very short reply. 1.27. What is the ratio of the Claims(annual growth as % of broad money) of Papua New Guinea in 2004 to that in 2005?
Offer a very short reply. 0.02. What is the ratio of the Claims(annual growth as % of broad money) of Costa Rica in 2004 to that in 2006?
Your answer should be very brief. 0.63. What is the ratio of the Claims(annual growth as % of broad money) in Namibia in 2004 to that in 2006?
Your answer should be compact. 1.1. What is the ratio of the Claims(annual growth as % of broad money) in Nepal in 2004 to that in 2006?
Make the answer very short. 0.71. What is the ratio of the Claims(annual growth as % of broad money) in Papua New Guinea in 2004 to that in 2006?
Make the answer very short. 0.01. What is the ratio of the Claims(annual growth as % of broad money) in Costa Rica in 2004 to that in 2007?
Ensure brevity in your answer.  0.45. What is the ratio of the Claims(annual growth as % of broad money) in Namibia in 2004 to that in 2007?
Give a very brief answer. 1.4. What is the ratio of the Claims(annual growth as % of broad money) in Nepal in 2004 to that in 2007?
Provide a succinct answer. 0.6. What is the ratio of the Claims(annual growth as % of broad money) of Papua New Guinea in 2004 to that in 2007?
Make the answer very short. 0.01. What is the ratio of the Claims(annual growth as % of broad money) in Costa Rica in 2004 to that in 2008?
Your answer should be compact. 0.47. What is the ratio of the Claims(annual growth as % of broad money) in Namibia in 2004 to that in 2008?
Offer a terse response. 1.48. What is the ratio of the Claims(annual growth as % of broad money) in Nepal in 2004 to that in 2008?
Your answer should be very brief. 0.26. What is the ratio of the Claims(annual growth as % of broad money) in Papua New Guinea in 2004 to that in 2008?
Your answer should be compact. 0.01. What is the ratio of the Claims(annual growth as % of broad money) in Costa Rica in 2004 to that in 2009?
Your answer should be very brief. 2.51. What is the ratio of the Claims(annual growth as % of broad money) in Namibia in 2004 to that in 2009?
Your response must be concise. 2.38. What is the ratio of the Claims(annual growth as % of broad money) of Nepal in 2004 to that in 2009?
Give a very brief answer. 0.33. What is the ratio of the Claims(annual growth as % of broad money) in Papua New Guinea in 2004 to that in 2009?
Your response must be concise. 0.02. What is the ratio of the Claims(annual growth as % of broad money) of Costa Rica in 2004 to that in 2010?
Offer a terse response. 2.62. What is the ratio of the Claims(annual growth as % of broad money) in Namibia in 2004 to that in 2010?
Your response must be concise. 2.56. What is the ratio of the Claims(annual growth as % of broad money) in Nepal in 2004 to that in 2010?
Offer a very short reply. 1. What is the ratio of the Claims(annual growth as % of broad money) of Papua New Guinea in 2004 to that in 2010?
Your response must be concise. 0.02. What is the ratio of the Claims(annual growth as % of broad money) of Costa Rica in 2005 to that in 2006?
Provide a succinct answer. 1.01. What is the ratio of the Claims(annual growth as % of broad money) in Namibia in 2005 to that in 2006?
Your answer should be compact. 1.08. What is the ratio of the Claims(annual growth as % of broad money) of Nepal in 2005 to that in 2006?
Make the answer very short. 0.55. What is the ratio of the Claims(annual growth as % of broad money) in Papua New Guinea in 2005 to that in 2006?
Offer a terse response. 0.72. What is the ratio of the Claims(annual growth as % of broad money) in Costa Rica in 2005 to that in 2007?
Your response must be concise. 0.73. What is the ratio of the Claims(annual growth as % of broad money) in Namibia in 2005 to that in 2007?
Your answer should be very brief. 1.39. What is the ratio of the Claims(annual growth as % of broad money) in Nepal in 2005 to that in 2007?
Make the answer very short. 0.48. What is the ratio of the Claims(annual growth as % of broad money) in Papua New Guinea in 2005 to that in 2007?
Provide a succinct answer. 0.79. What is the ratio of the Claims(annual growth as % of broad money) of Costa Rica in 2005 to that in 2008?
Offer a terse response. 0.76. What is the ratio of the Claims(annual growth as % of broad money) of Namibia in 2005 to that in 2008?
Give a very brief answer. 1.46. What is the ratio of the Claims(annual growth as % of broad money) of Nepal in 2005 to that in 2008?
Give a very brief answer. 0.2. What is the ratio of the Claims(annual growth as % of broad money) of Papua New Guinea in 2005 to that in 2008?
Provide a short and direct response. 0.83. What is the ratio of the Claims(annual growth as % of broad money) in Costa Rica in 2005 to that in 2009?
Your response must be concise. 4.05. What is the ratio of the Claims(annual growth as % of broad money) of Namibia in 2005 to that in 2009?
Keep it short and to the point. 2.35. What is the ratio of the Claims(annual growth as % of broad money) in Nepal in 2005 to that in 2009?
Offer a very short reply. 0.26. What is the ratio of the Claims(annual growth as % of broad money) of Papua New Guinea in 2005 to that in 2009?
Give a very brief answer. 1.35. What is the ratio of the Claims(annual growth as % of broad money) in Costa Rica in 2005 to that in 2010?
Offer a very short reply. 4.24. What is the ratio of the Claims(annual growth as % of broad money) of Namibia in 2005 to that in 2010?
Provide a short and direct response. 2.53. What is the ratio of the Claims(annual growth as % of broad money) in Nepal in 2005 to that in 2010?
Ensure brevity in your answer.  0.78. What is the ratio of the Claims(annual growth as % of broad money) of Papua New Guinea in 2005 to that in 2010?
Ensure brevity in your answer.  1.21. What is the ratio of the Claims(annual growth as % of broad money) in Costa Rica in 2006 to that in 2007?
Offer a terse response. 0.72. What is the ratio of the Claims(annual growth as % of broad money) of Namibia in 2006 to that in 2007?
Offer a terse response. 1.28. What is the ratio of the Claims(annual growth as % of broad money) in Nepal in 2006 to that in 2007?
Provide a short and direct response. 0.86. What is the ratio of the Claims(annual growth as % of broad money) in Papua New Guinea in 2006 to that in 2007?
Your answer should be compact. 1.09. What is the ratio of the Claims(annual growth as % of broad money) of Costa Rica in 2006 to that in 2008?
Provide a succinct answer. 0.75. What is the ratio of the Claims(annual growth as % of broad money) of Namibia in 2006 to that in 2008?
Offer a very short reply. 1.35. What is the ratio of the Claims(annual growth as % of broad money) of Nepal in 2006 to that in 2008?
Your answer should be very brief. 0.37. What is the ratio of the Claims(annual growth as % of broad money) in Papua New Guinea in 2006 to that in 2008?
Keep it short and to the point. 1.15. What is the ratio of the Claims(annual growth as % of broad money) in Costa Rica in 2006 to that in 2009?
Provide a succinct answer. 3.99. What is the ratio of the Claims(annual growth as % of broad money) of Namibia in 2006 to that in 2009?
Make the answer very short. 2.17. What is the ratio of the Claims(annual growth as % of broad money) of Nepal in 2006 to that in 2009?
Offer a very short reply. 0.47. What is the ratio of the Claims(annual growth as % of broad money) in Papua New Guinea in 2006 to that in 2009?
Offer a terse response. 1.88. What is the ratio of the Claims(annual growth as % of broad money) in Costa Rica in 2006 to that in 2010?
Ensure brevity in your answer.  4.18. What is the ratio of the Claims(annual growth as % of broad money) in Namibia in 2006 to that in 2010?
Your answer should be compact. 2.34. What is the ratio of the Claims(annual growth as % of broad money) in Nepal in 2006 to that in 2010?
Provide a succinct answer. 1.41. What is the ratio of the Claims(annual growth as % of broad money) in Papua New Guinea in 2006 to that in 2010?
Offer a terse response. 1.68. What is the ratio of the Claims(annual growth as % of broad money) of Costa Rica in 2007 to that in 2008?
Ensure brevity in your answer.  1.03. What is the ratio of the Claims(annual growth as % of broad money) in Namibia in 2007 to that in 2008?
Provide a succinct answer. 1.05. What is the ratio of the Claims(annual growth as % of broad money) of Nepal in 2007 to that in 2008?
Offer a terse response. 0.43. What is the ratio of the Claims(annual growth as % of broad money) of Papua New Guinea in 2007 to that in 2008?
Provide a short and direct response. 1.05. What is the ratio of the Claims(annual growth as % of broad money) of Costa Rica in 2007 to that in 2009?
Provide a succinct answer. 5.54. What is the ratio of the Claims(annual growth as % of broad money) of Namibia in 2007 to that in 2009?
Provide a short and direct response. 1.69. What is the ratio of the Claims(annual growth as % of broad money) in Nepal in 2007 to that in 2009?
Make the answer very short. 0.55. What is the ratio of the Claims(annual growth as % of broad money) of Papua New Guinea in 2007 to that in 2009?
Make the answer very short. 1.72. What is the ratio of the Claims(annual growth as % of broad money) in Costa Rica in 2007 to that in 2010?
Make the answer very short. 5.8. What is the ratio of the Claims(annual growth as % of broad money) in Namibia in 2007 to that in 2010?
Keep it short and to the point. 1.83. What is the ratio of the Claims(annual growth as % of broad money) of Nepal in 2007 to that in 2010?
Offer a very short reply. 1.65. What is the ratio of the Claims(annual growth as % of broad money) of Papua New Guinea in 2007 to that in 2010?
Provide a succinct answer. 1.54. What is the ratio of the Claims(annual growth as % of broad money) of Costa Rica in 2008 to that in 2009?
Your answer should be very brief. 5.36. What is the ratio of the Claims(annual growth as % of broad money) in Namibia in 2008 to that in 2009?
Make the answer very short. 1.61. What is the ratio of the Claims(annual growth as % of broad money) in Nepal in 2008 to that in 2009?
Offer a terse response. 1.27. What is the ratio of the Claims(annual growth as % of broad money) of Papua New Guinea in 2008 to that in 2009?
Keep it short and to the point. 1.64. What is the ratio of the Claims(annual growth as % of broad money) in Costa Rica in 2008 to that in 2010?
Offer a very short reply. 5.61. What is the ratio of the Claims(annual growth as % of broad money) in Namibia in 2008 to that in 2010?
Offer a very short reply. 1.73. What is the ratio of the Claims(annual growth as % of broad money) of Nepal in 2008 to that in 2010?
Your answer should be very brief. 3.84. What is the ratio of the Claims(annual growth as % of broad money) in Papua New Guinea in 2008 to that in 2010?
Make the answer very short. 1.47. What is the ratio of the Claims(annual growth as % of broad money) in Costa Rica in 2009 to that in 2010?
Provide a short and direct response. 1.05. What is the ratio of the Claims(annual growth as % of broad money) in Namibia in 2009 to that in 2010?
Offer a terse response. 1.08. What is the ratio of the Claims(annual growth as % of broad money) in Nepal in 2009 to that in 2010?
Offer a very short reply. 3.02. What is the ratio of the Claims(annual growth as % of broad money) of Papua New Guinea in 2009 to that in 2010?
Your answer should be very brief. 0.9. What is the difference between the highest and the second highest Claims(annual growth as % of broad money) of Costa Rica?
Offer a terse response. 0.89. What is the difference between the highest and the second highest Claims(annual growth as % of broad money) in Namibia?
Your answer should be compact. 0.31. What is the difference between the highest and the second highest Claims(annual growth as % of broad money) in Nepal?
Keep it short and to the point. 7.33. What is the difference between the highest and the second highest Claims(annual growth as % of broad money) in Papua New Guinea?
Make the answer very short. 1.3. What is the difference between the highest and the lowest Claims(annual growth as % of broad money) of Costa Rica?
Keep it short and to the point. 22.36. What is the difference between the highest and the lowest Claims(annual growth as % of broad money) in Namibia?
Give a very brief answer. 15.48. What is the difference between the highest and the lowest Claims(annual growth as % of broad money) of Nepal?
Provide a succinct answer. 27.27. What is the difference between the highest and the lowest Claims(annual growth as % of broad money) in Papua New Guinea?
Offer a terse response. 15.69. 